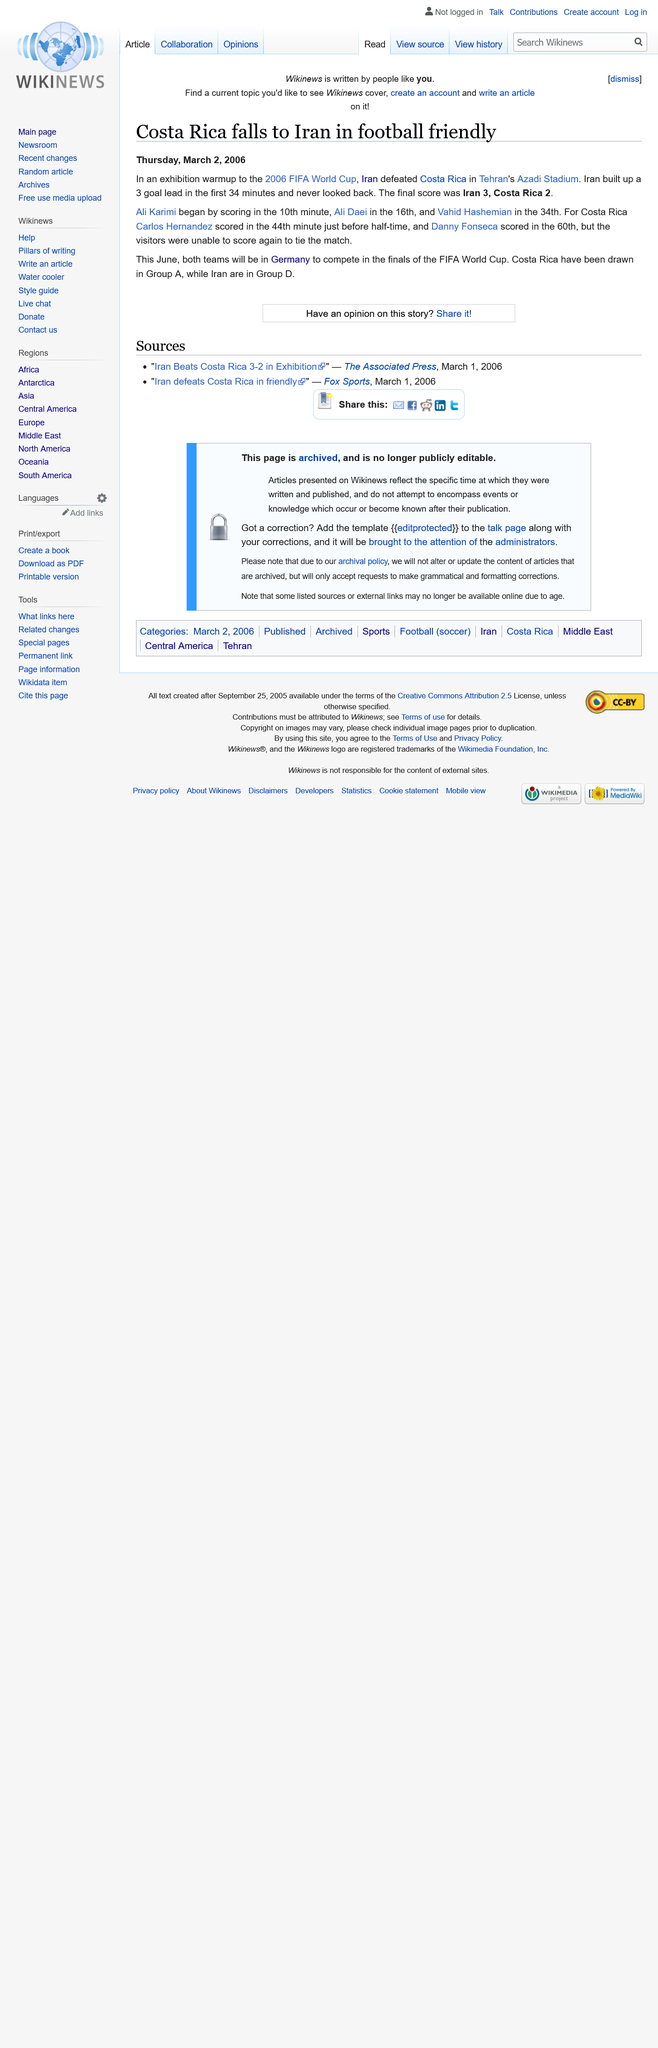Indicate a few pertinent items in this graphic. The 2006 FIFA World Cup will be held in Germany. The football friendly was held at Tehran's Azadi Stadium. The final score of the exhibition warmup was Iran 3, Costa Rica 2. 